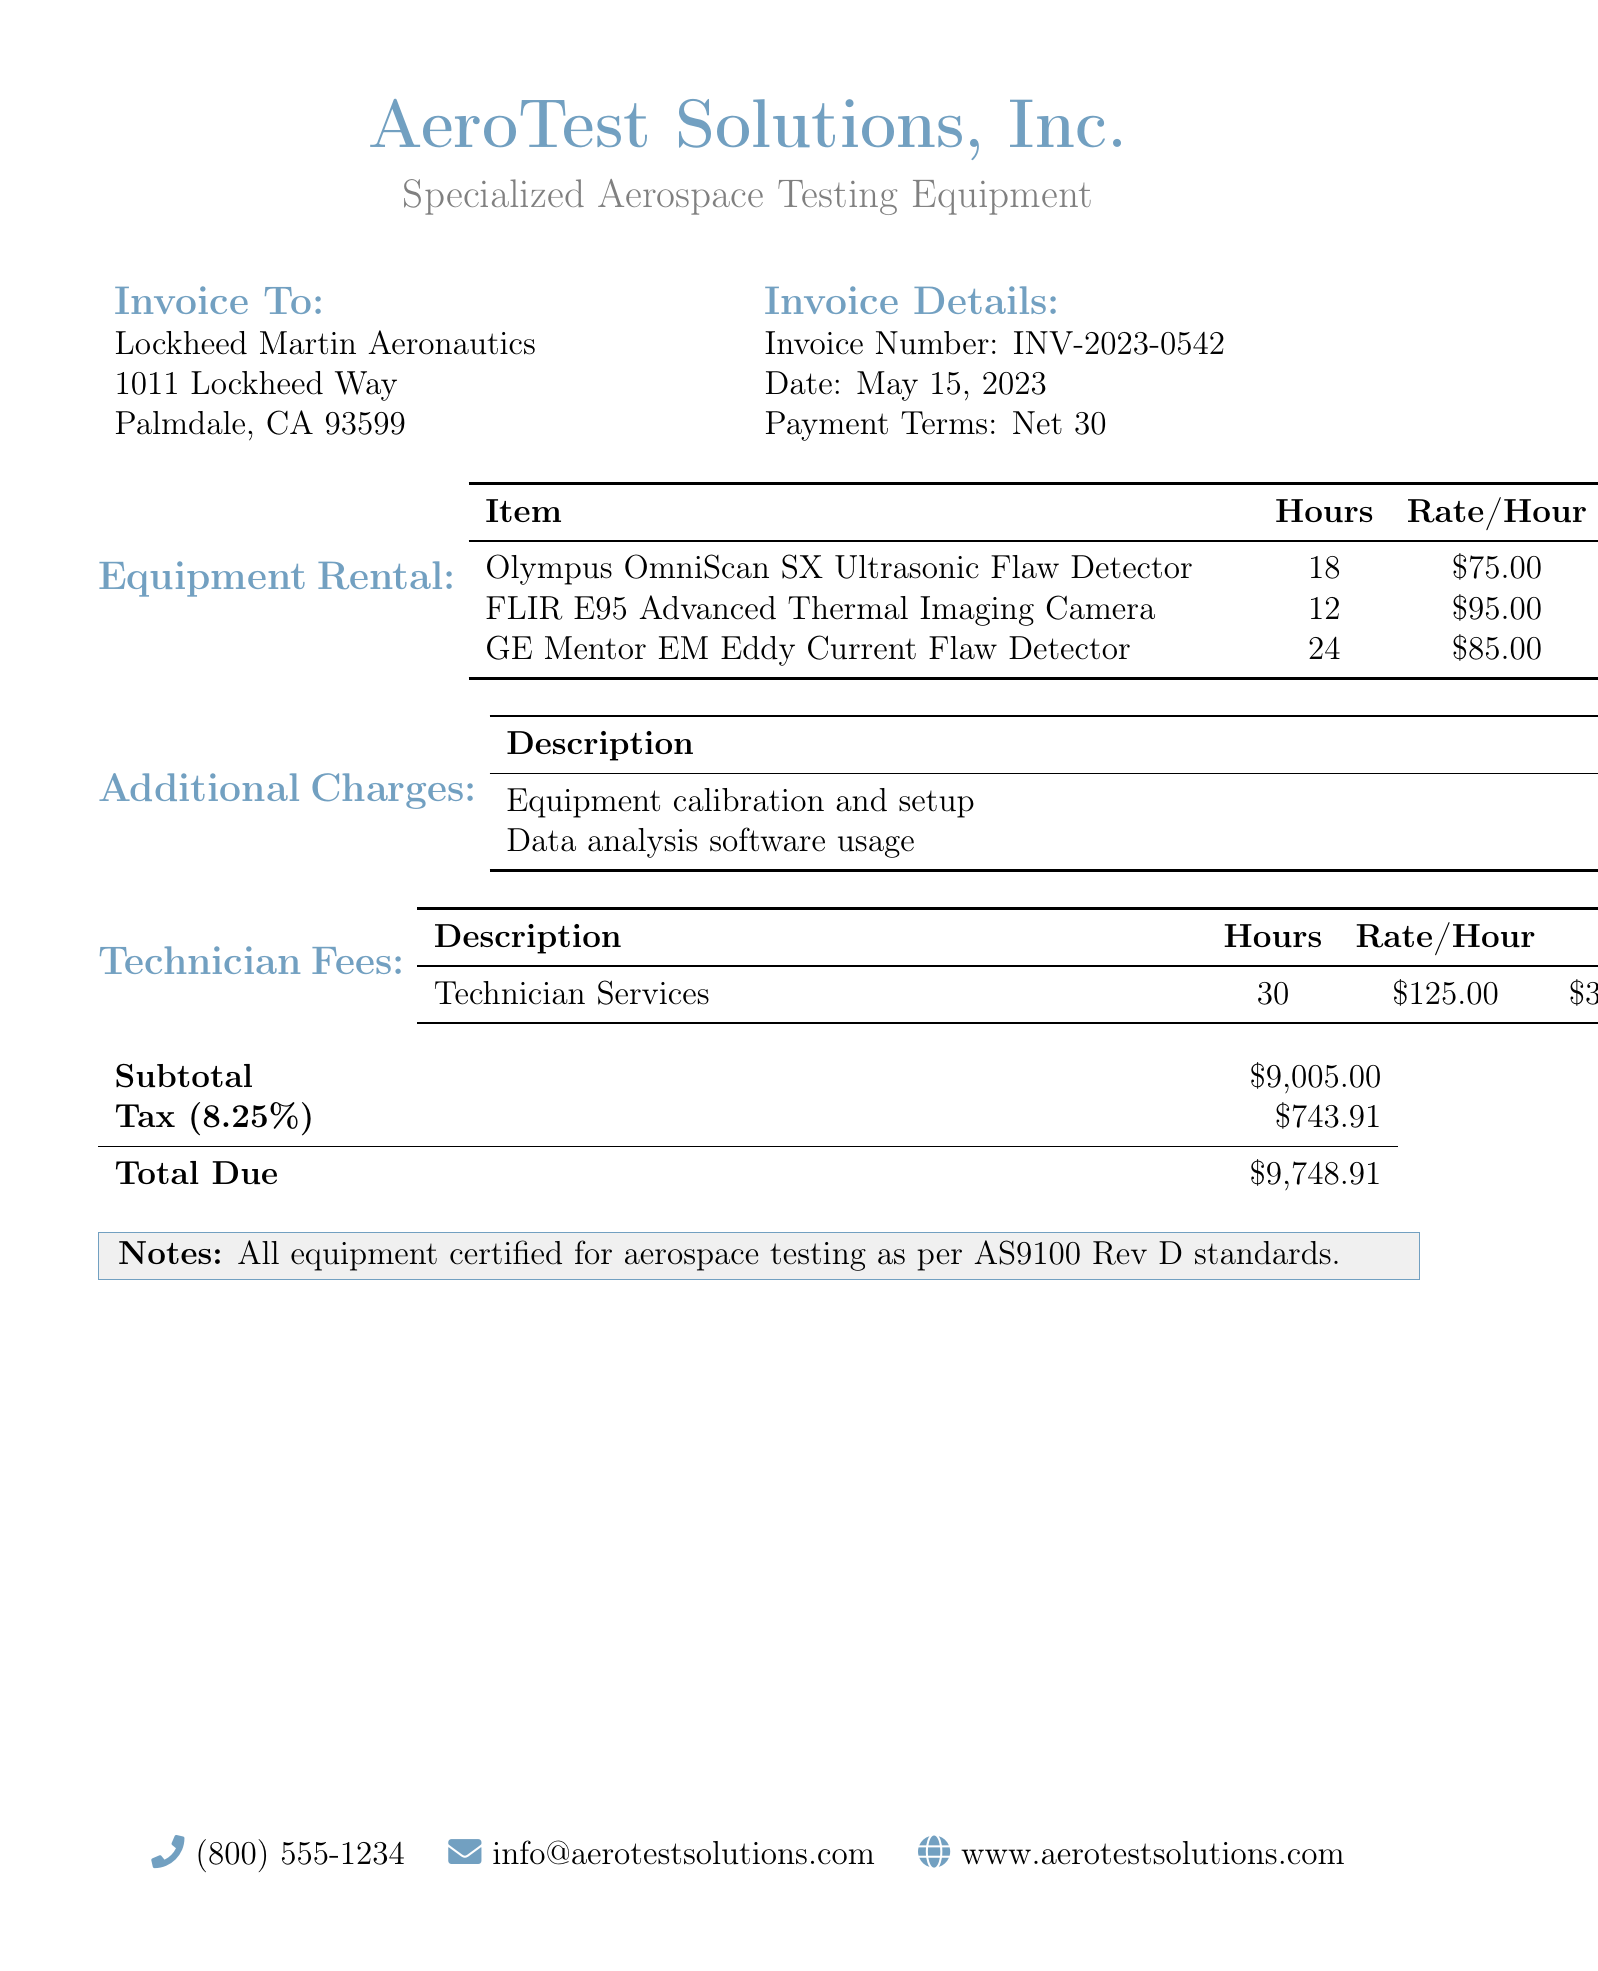What is the invoice number? The invoice number is listed in the document under Invoice Details as INV-2023-0542.
Answer: INV-2023-0542 What is the total amount due? The total amount due is calculated at the bottom of the document, which is $9,748.91.
Answer: $9,748.91 How many hours was the GE Mentor EM Eddy Current Flaw Detector rented? The rental duration for the GE Mentor EM Eddy Current Flaw Detector is indicated as 24 hours in the Equipment Rental section.
Answer: 24 What is the rate per hour for the FLIR E95 Advanced Thermal Imaging Camera? The document states that the rate per hour for the FLIR E95 Advanced Thermal Imaging Camera is $95.00.
Answer: $95.00 What is the subtotal before tax? The subtotal before tax is shown in the document as $9,005.00.
Answer: $9,005.00 How much was charged for technician services? The total charged for technician services can be found under Technician Fees, amounting to $3,750.00.
Answer: $3,750.00 What is the tax percentage applied to the subtotal? The tax percentage applied is stated as 8.25% in the Tax line of the invoice.
Answer: 8.25% How much is charged for equipment calibration and setup? The charge for equipment calibration and setup is listed under Additional Charges as $450.00.
Answer: $450.00 What is the date of the invoice? The invoice date can be found in Invoice Details and is listed as May 15, 2023.
Answer: May 15, 2023 